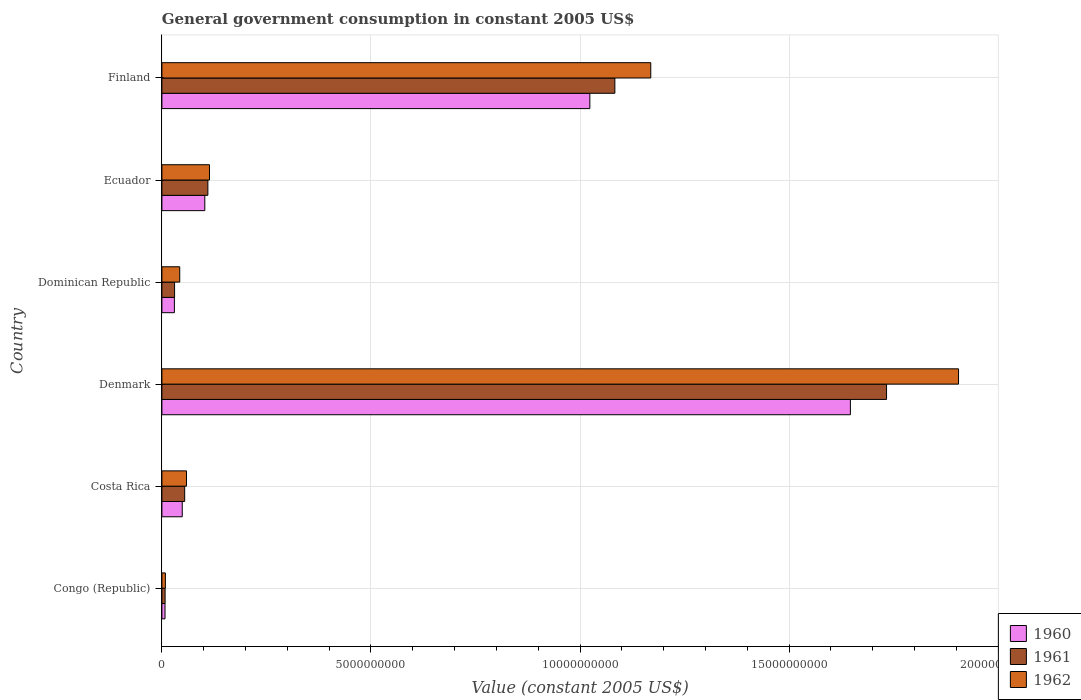How many groups of bars are there?
Keep it short and to the point. 6. Are the number of bars on each tick of the Y-axis equal?
Your answer should be compact. Yes. How many bars are there on the 5th tick from the top?
Provide a short and direct response. 3. How many bars are there on the 3rd tick from the bottom?
Make the answer very short. 3. What is the label of the 2nd group of bars from the top?
Keep it short and to the point. Ecuador. What is the government conusmption in 1962 in Costa Rica?
Make the answer very short. 5.88e+08. Across all countries, what is the maximum government conusmption in 1960?
Provide a short and direct response. 1.65e+1. Across all countries, what is the minimum government conusmption in 1960?
Ensure brevity in your answer.  7.44e+07. In which country was the government conusmption in 1960 minimum?
Make the answer very short. Congo (Republic). What is the total government conusmption in 1961 in the graph?
Offer a terse response. 3.02e+1. What is the difference between the government conusmption in 1962 in Congo (Republic) and that in Denmark?
Your answer should be compact. -1.90e+1. What is the difference between the government conusmption in 1961 in Denmark and the government conusmption in 1962 in Dominican Republic?
Offer a terse response. 1.69e+1. What is the average government conusmption in 1960 per country?
Provide a short and direct response. 4.76e+09. What is the difference between the government conusmption in 1962 and government conusmption in 1961 in Ecuador?
Provide a short and direct response. 3.85e+07. In how many countries, is the government conusmption in 1962 greater than 13000000000 US$?
Give a very brief answer. 1. What is the ratio of the government conusmption in 1962 in Congo (Republic) to that in Finland?
Provide a short and direct response. 0.01. Is the government conusmption in 1962 in Costa Rica less than that in Ecuador?
Provide a succinct answer. Yes. Is the difference between the government conusmption in 1962 in Costa Rica and Dominican Republic greater than the difference between the government conusmption in 1961 in Costa Rica and Dominican Republic?
Your response must be concise. No. What is the difference between the highest and the second highest government conusmption in 1962?
Offer a terse response. 7.36e+09. What is the difference between the highest and the lowest government conusmption in 1960?
Make the answer very short. 1.64e+1. Is the sum of the government conusmption in 1960 in Costa Rica and Ecuador greater than the maximum government conusmption in 1962 across all countries?
Offer a terse response. No. Is it the case that in every country, the sum of the government conusmption in 1961 and government conusmption in 1962 is greater than the government conusmption in 1960?
Provide a short and direct response. Yes. Are all the bars in the graph horizontal?
Provide a succinct answer. Yes. Does the graph contain any zero values?
Make the answer very short. No. Does the graph contain grids?
Your response must be concise. Yes. Where does the legend appear in the graph?
Make the answer very short. Bottom right. What is the title of the graph?
Your answer should be compact. General government consumption in constant 2005 US$. What is the label or title of the X-axis?
Give a very brief answer. Value (constant 2005 US$). What is the label or title of the Y-axis?
Your response must be concise. Country. What is the Value (constant 2005 US$) of 1960 in Congo (Republic)?
Keep it short and to the point. 7.44e+07. What is the Value (constant 2005 US$) of 1961 in Congo (Republic)?
Your answer should be very brief. 7.67e+07. What is the Value (constant 2005 US$) of 1962 in Congo (Republic)?
Offer a terse response. 8.33e+07. What is the Value (constant 2005 US$) in 1960 in Costa Rica?
Offer a terse response. 4.87e+08. What is the Value (constant 2005 US$) in 1961 in Costa Rica?
Ensure brevity in your answer.  5.45e+08. What is the Value (constant 2005 US$) of 1962 in Costa Rica?
Your answer should be very brief. 5.88e+08. What is the Value (constant 2005 US$) in 1960 in Denmark?
Make the answer very short. 1.65e+1. What is the Value (constant 2005 US$) of 1961 in Denmark?
Give a very brief answer. 1.73e+1. What is the Value (constant 2005 US$) of 1962 in Denmark?
Your response must be concise. 1.91e+1. What is the Value (constant 2005 US$) of 1960 in Dominican Republic?
Provide a succinct answer. 2.99e+08. What is the Value (constant 2005 US$) of 1961 in Dominican Republic?
Offer a very short reply. 3.03e+08. What is the Value (constant 2005 US$) of 1962 in Dominican Republic?
Your answer should be compact. 4.27e+08. What is the Value (constant 2005 US$) of 1960 in Ecuador?
Your response must be concise. 1.03e+09. What is the Value (constant 2005 US$) of 1961 in Ecuador?
Give a very brief answer. 1.10e+09. What is the Value (constant 2005 US$) of 1962 in Ecuador?
Offer a very short reply. 1.14e+09. What is the Value (constant 2005 US$) of 1960 in Finland?
Make the answer very short. 1.02e+1. What is the Value (constant 2005 US$) of 1961 in Finland?
Offer a very short reply. 1.08e+1. What is the Value (constant 2005 US$) in 1962 in Finland?
Your answer should be compact. 1.17e+1. Across all countries, what is the maximum Value (constant 2005 US$) of 1960?
Give a very brief answer. 1.65e+1. Across all countries, what is the maximum Value (constant 2005 US$) of 1961?
Give a very brief answer. 1.73e+1. Across all countries, what is the maximum Value (constant 2005 US$) of 1962?
Offer a terse response. 1.91e+1. Across all countries, what is the minimum Value (constant 2005 US$) of 1960?
Your answer should be very brief. 7.44e+07. Across all countries, what is the minimum Value (constant 2005 US$) in 1961?
Give a very brief answer. 7.67e+07. Across all countries, what is the minimum Value (constant 2005 US$) in 1962?
Give a very brief answer. 8.33e+07. What is the total Value (constant 2005 US$) in 1960 in the graph?
Offer a terse response. 2.86e+1. What is the total Value (constant 2005 US$) in 1961 in the graph?
Provide a short and direct response. 3.02e+1. What is the total Value (constant 2005 US$) in 1962 in the graph?
Your response must be concise. 3.30e+1. What is the difference between the Value (constant 2005 US$) of 1960 in Congo (Republic) and that in Costa Rica?
Ensure brevity in your answer.  -4.12e+08. What is the difference between the Value (constant 2005 US$) in 1961 in Congo (Republic) and that in Costa Rica?
Offer a very short reply. -4.68e+08. What is the difference between the Value (constant 2005 US$) in 1962 in Congo (Republic) and that in Costa Rica?
Your answer should be compact. -5.05e+08. What is the difference between the Value (constant 2005 US$) of 1960 in Congo (Republic) and that in Denmark?
Ensure brevity in your answer.  -1.64e+1. What is the difference between the Value (constant 2005 US$) in 1961 in Congo (Republic) and that in Denmark?
Make the answer very short. -1.73e+1. What is the difference between the Value (constant 2005 US$) of 1962 in Congo (Republic) and that in Denmark?
Provide a short and direct response. -1.90e+1. What is the difference between the Value (constant 2005 US$) in 1960 in Congo (Republic) and that in Dominican Republic?
Give a very brief answer. -2.24e+08. What is the difference between the Value (constant 2005 US$) in 1961 in Congo (Republic) and that in Dominican Republic?
Your answer should be very brief. -2.27e+08. What is the difference between the Value (constant 2005 US$) of 1962 in Congo (Republic) and that in Dominican Republic?
Offer a very short reply. -3.43e+08. What is the difference between the Value (constant 2005 US$) in 1960 in Congo (Republic) and that in Ecuador?
Your response must be concise. -9.51e+08. What is the difference between the Value (constant 2005 US$) in 1961 in Congo (Republic) and that in Ecuador?
Give a very brief answer. -1.02e+09. What is the difference between the Value (constant 2005 US$) of 1962 in Congo (Republic) and that in Ecuador?
Provide a short and direct response. -1.05e+09. What is the difference between the Value (constant 2005 US$) of 1960 in Congo (Republic) and that in Finland?
Provide a succinct answer. -1.02e+1. What is the difference between the Value (constant 2005 US$) in 1961 in Congo (Republic) and that in Finland?
Provide a short and direct response. -1.08e+1. What is the difference between the Value (constant 2005 US$) of 1962 in Congo (Republic) and that in Finland?
Your answer should be very brief. -1.16e+1. What is the difference between the Value (constant 2005 US$) in 1960 in Costa Rica and that in Denmark?
Your answer should be compact. -1.60e+1. What is the difference between the Value (constant 2005 US$) in 1961 in Costa Rica and that in Denmark?
Offer a terse response. -1.68e+1. What is the difference between the Value (constant 2005 US$) in 1962 in Costa Rica and that in Denmark?
Your answer should be very brief. -1.85e+1. What is the difference between the Value (constant 2005 US$) in 1960 in Costa Rica and that in Dominican Republic?
Provide a succinct answer. 1.88e+08. What is the difference between the Value (constant 2005 US$) in 1961 in Costa Rica and that in Dominican Republic?
Provide a succinct answer. 2.41e+08. What is the difference between the Value (constant 2005 US$) in 1962 in Costa Rica and that in Dominican Republic?
Ensure brevity in your answer.  1.61e+08. What is the difference between the Value (constant 2005 US$) in 1960 in Costa Rica and that in Ecuador?
Make the answer very short. -5.39e+08. What is the difference between the Value (constant 2005 US$) of 1961 in Costa Rica and that in Ecuador?
Your answer should be very brief. -5.55e+08. What is the difference between the Value (constant 2005 US$) in 1962 in Costa Rica and that in Ecuador?
Provide a succinct answer. -5.50e+08. What is the difference between the Value (constant 2005 US$) of 1960 in Costa Rica and that in Finland?
Keep it short and to the point. -9.75e+09. What is the difference between the Value (constant 2005 US$) of 1961 in Costa Rica and that in Finland?
Keep it short and to the point. -1.03e+1. What is the difference between the Value (constant 2005 US$) of 1962 in Costa Rica and that in Finland?
Your response must be concise. -1.11e+1. What is the difference between the Value (constant 2005 US$) of 1960 in Denmark and that in Dominican Republic?
Keep it short and to the point. 1.62e+1. What is the difference between the Value (constant 2005 US$) in 1961 in Denmark and that in Dominican Republic?
Make the answer very short. 1.70e+1. What is the difference between the Value (constant 2005 US$) in 1962 in Denmark and that in Dominican Republic?
Offer a very short reply. 1.86e+1. What is the difference between the Value (constant 2005 US$) in 1960 in Denmark and that in Ecuador?
Provide a short and direct response. 1.54e+1. What is the difference between the Value (constant 2005 US$) in 1961 in Denmark and that in Ecuador?
Give a very brief answer. 1.62e+1. What is the difference between the Value (constant 2005 US$) in 1962 in Denmark and that in Ecuador?
Provide a short and direct response. 1.79e+1. What is the difference between the Value (constant 2005 US$) in 1960 in Denmark and that in Finland?
Offer a terse response. 6.23e+09. What is the difference between the Value (constant 2005 US$) of 1961 in Denmark and that in Finland?
Keep it short and to the point. 6.50e+09. What is the difference between the Value (constant 2005 US$) of 1962 in Denmark and that in Finland?
Your response must be concise. 7.36e+09. What is the difference between the Value (constant 2005 US$) of 1960 in Dominican Republic and that in Ecuador?
Provide a short and direct response. -7.27e+08. What is the difference between the Value (constant 2005 US$) of 1961 in Dominican Republic and that in Ecuador?
Your answer should be compact. -7.96e+08. What is the difference between the Value (constant 2005 US$) of 1962 in Dominican Republic and that in Ecuador?
Provide a succinct answer. -7.11e+08. What is the difference between the Value (constant 2005 US$) of 1960 in Dominican Republic and that in Finland?
Ensure brevity in your answer.  -9.94e+09. What is the difference between the Value (constant 2005 US$) of 1961 in Dominican Republic and that in Finland?
Provide a succinct answer. -1.05e+1. What is the difference between the Value (constant 2005 US$) in 1962 in Dominican Republic and that in Finland?
Your answer should be very brief. -1.13e+1. What is the difference between the Value (constant 2005 US$) in 1960 in Ecuador and that in Finland?
Offer a very short reply. -9.21e+09. What is the difference between the Value (constant 2005 US$) in 1961 in Ecuador and that in Finland?
Make the answer very short. -9.73e+09. What is the difference between the Value (constant 2005 US$) of 1962 in Ecuador and that in Finland?
Your answer should be very brief. -1.06e+1. What is the difference between the Value (constant 2005 US$) in 1960 in Congo (Republic) and the Value (constant 2005 US$) in 1961 in Costa Rica?
Give a very brief answer. -4.70e+08. What is the difference between the Value (constant 2005 US$) of 1960 in Congo (Republic) and the Value (constant 2005 US$) of 1962 in Costa Rica?
Offer a terse response. -5.13e+08. What is the difference between the Value (constant 2005 US$) of 1961 in Congo (Republic) and the Value (constant 2005 US$) of 1962 in Costa Rica?
Your answer should be very brief. -5.11e+08. What is the difference between the Value (constant 2005 US$) in 1960 in Congo (Republic) and the Value (constant 2005 US$) in 1961 in Denmark?
Your answer should be compact. -1.73e+1. What is the difference between the Value (constant 2005 US$) of 1960 in Congo (Republic) and the Value (constant 2005 US$) of 1962 in Denmark?
Ensure brevity in your answer.  -1.90e+1. What is the difference between the Value (constant 2005 US$) of 1961 in Congo (Republic) and the Value (constant 2005 US$) of 1962 in Denmark?
Give a very brief answer. -1.90e+1. What is the difference between the Value (constant 2005 US$) in 1960 in Congo (Republic) and the Value (constant 2005 US$) in 1961 in Dominican Republic?
Your response must be concise. -2.29e+08. What is the difference between the Value (constant 2005 US$) of 1960 in Congo (Republic) and the Value (constant 2005 US$) of 1962 in Dominican Republic?
Your answer should be very brief. -3.52e+08. What is the difference between the Value (constant 2005 US$) in 1961 in Congo (Republic) and the Value (constant 2005 US$) in 1962 in Dominican Republic?
Provide a succinct answer. -3.50e+08. What is the difference between the Value (constant 2005 US$) in 1960 in Congo (Republic) and the Value (constant 2005 US$) in 1961 in Ecuador?
Your response must be concise. -1.02e+09. What is the difference between the Value (constant 2005 US$) in 1960 in Congo (Republic) and the Value (constant 2005 US$) in 1962 in Ecuador?
Offer a terse response. -1.06e+09. What is the difference between the Value (constant 2005 US$) of 1961 in Congo (Republic) and the Value (constant 2005 US$) of 1962 in Ecuador?
Keep it short and to the point. -1.06e+09. What is the difference between the Value (constant 2005 US$) in 1960 in Congo (Republic) and the Value (constant 2005 US$) in 1961 in Finland?
Your answer should be compact. -1.08e+1. What is the difference between the Value (constant 2005 US$) in 1960 in Congo (Republic) and the Value (constant 2005 US$) in 1962 in Finland?
Offer a very short reply. -1.16e+1. What is the difference between the Value (constant 2005 US$) of 1961 in Congo (Republic) and the Value (constant 2005 US$) of 1962 in Finland?
Make the answer very short. -1.16e+1. What is the difference between the Value (constant 2005 US$) of 1960 in Costa Rica and the Value (constant 2005 US$) of 1961 in Denmark?
Keep it short and to the point. -1.68e+1. What is the difference between the Value (constant 2005 US$) in 1960 in Costa Rica and the Value (constant 2005 US$) in 1962 in Denmark?
Keep it short and to the point. -1.86e+1. What is the difference between the Value (constant 2005 US$) in 1961 in Costa Rica and the Value (constant 2005 US$) in 1962 in Denmark?
Provide a succinct answer. -1.85e+1. What is the difference between the Value (constant 2005 US$) in 1960 in Costa Rica and the Value (constant 2005 US$) in 1961 in Dominican Republic?
Make the answer very short. 1.83e+08. What is the difference between the Value (constant 2005 US$) in 1960 in Costa Rica and the Value (constant 2005 US$) in 1962 in Dominican Republic?
Offer a terse response. 6.01e+07. What is the difference between the Value (constant 2005 US$) of 1961 in Costa Rica and the Value (constant 2005 US$) of 1962 in Dominican Republic?
Ensure brevity in your answer.  1.18e+08. What is the difference between the Value (constant 2005 US$) in 1960 in Costa Rica and the Value (constant 2005 US$) in 1961 in Ecuador?
Your response must be concise. -6.13e+08. What is the difference between the Value (constant 2005 US$) of 1960 in Costa Rica and the Value (constant 2005 US$) of 1962 in Ecuador?
Ensure brevity in your answer.  -6.51e+08. What is the difference between the Value (constant 2005 US$) in 1961 in Costa Rica and the Value (constant 2005 US$) in 1962 in Ecuador?
Offer a terse response. -5.93e+08. What is the difference between the Value (constant 2005 US$) in 1960 in Costa Rica and the Value (constant 2005 US$) in 1961 in Finland?
Ensure brevity in your answer.  -1.03e+1. What is the difference between the Value (constant 2005 US$) of 1960 in Costa Rica and the Value (constant 2005 US$) of 1962 in Finland?
Offer a terse response. -1.12e+1. What is the difference between the Value (constant 2005 US$) of 1961 in Costa Rica and the Value (constant 2005 US$) of 1962 in Finland?
Provide a short and direct response. -1.11e+1. What is the difference between the Value (constant 2005 US$) of 1960 in Denmark and the Value (constant 2005 US$) of 1961 in Dominican Republic?
Give a very brief answer. 1.62e+1. What is the difference between the Value (constant 2005 US$) of 1960 in Denmark and the Value (constant 2005 US$) of 1962 in Dominican Republic?
Give a very brief answer. 1.60e+1. What is the difference between the Value (constant 2005 US$) in 1961 in Denmark and the Value (constant 2005 US$) in 1962 in Dominican Republic?
Your response must be concise. 1.69e+1. What is the difference between the Value (constant 2005 US$) of 1960 in Denmark and the Value (constant 2005 US$) of 1961 in Ecuador?
Make the answer very short. 1.54e+1. What is the difference between the Value (constant 2005 US$) in 1960 in Denmark and the Value (constant 2005 US$) in 1962 in Ecuador?
Make the answer very short. 1.53e+1. What is the difference between the Value (constant 2005 US$) of 1961 in Denmark and the Value (constant 2005 US$) of 1962 in Ecuador?
Keep it short and to the point. 1.62e+1. What is the difference between the Value (constant 2005 US$) of 1960 in Denmark and the Value (constant 2005 US$) of 1961 in Finland?
Provide a short and direct response. 5.63e+09. What is the difference between the Value (constant 2005 US$) of 1960 in Denmark and the Value (constant 2005 US$) of 1962 in Finland?
Make the answer very short. 4.77e+09. What is the difference between the Value (constant 2005 US$) of 1961 in Denmark and the Value (constant 2005 US$) of 1962 in Finland?
Offer a terse response. 5.64e+09. What is the difference between the Value (constant 2005 US$) of 1960 in Dominican Republic and the Value (constant 2005 US$) of 1961 in Ecuador?
Your response must be concise. -8.01e+08. What is the difference between the Value (constant 2005 US$) of 1960 in Dominican Republic and the Value (constant 2005 US$) of 1962 in Ecuador?
Ensure brevity in your answer.  -8.39e+08. What is the difference between the Value (constant 2005 US$) of 1961 in Dominican Republic and the Value (constant 2005 US$) of 1962 in Ecuador?
Give a very brief answer. -8.35e+08. What is the difference between the Value (constant 2005 US$) in 1960 in Dominican Republic and the Value (constant 2005 US$) in 1961 in Finland?
Provide a succinct answer. -1.05e+1. What is the difference between the Value (constant 2005 US$) of 1960 in Dominican Republic and the Value (constant 2005 US$) of 1962 in Finland?
Ensure brevity in your answer.  -1.14e+1. What is the difference between the Value (constant 2005 US$) in 1961 in Dominican Republic and the Value (constant 2005 US$) in 1962 in Finland?
Provide a short and direct response. -1.14e+1. What is the difference between the Value (constant 2005 US$) of 1960 in Ecuador and the Value (constant 2005 US$) of 1961 in Finland?
Offer a terse response. -9.81e+09. What is the difference between the Value (constant 2005 US$) of 1960 in Ecuador and the Value (constant 2005 US$) of 1962 in Finland?
Ensure brevity in your answer.  -1.07e+1. What is the difference between the Value (constant 2005 US$) of 1961 in Ecuador and the Value (constant 2005 US$) of 1962 in Finland?
Provide a succinct answer. -1.06e+1. What is the average Value (constant 2005 US$) in 1960 per country?
Provide a short and direct response. 4.76e+09. What is the average Value (constant 2005 US$) of 1961 per country?
Ensure brevity in your answer.  5.03e+09. What is the average Value (constant 2005 US$) in 1962 per country?
Ensure brevity in your answer.  5.50e+09. What is the difference between the Value (constant 2005 US$) of 1960 and Value (constant 2005 US$) of 1961 in Congo (Republic)?
Give a very brief answer. -2.22e+06. What is the difference between the Value (constant 2005 US$) of 1960 and Value (constant 2005 US$) of 1962 in Congo (Republic)?
Offer a terse response. -8.89e+06. What is the difference between the Value (constant 2005 US$) of 1961 and Value (constant 2005 US$) of 1962 in Congo (Republic)?
Provide a short and direct response. -6.67e+06. What is the difference between the Value (constant 2005 US$) in 1960 and Value (constant 2005 US$) in 1961 in Costa Rica?
Provide a succinct answer. -5.79e+07. What is the difference between the Value (constant 2005 US$) of 1960 and Value (constant 2005 US$) of 1962 in Costa Rica?
Ensure brevity in your answer.  -1.01e+08. What is the difference between the Value (constant 2005 US$) in 1961 and Value (constant 2005 US$) in 1962 in Costa Rica?
Your response must be concise. -4.32e+07. What is the difference between the Value (constant 2005 US$) in 1960 and Value (constant 2005 US$) in 1961 in Denmark?
Your answer should be very brief. -8.65e+08. What is the difference between the Value (constant 2005 US$) of 1960 and Value (constant 2005 US$) of 1962 in Denmark?
Ensure brevity in your answer.  -2.59e+09. What is the difference between the Value (constant 2005 US$) in 1961 and Value (constant 2005 US$) in 1962 in Denmark?
Provide a succinct answer. -1.72e+09. What is the difference between the Value (constant 2005 US$) of 1960 and Value (constant 2005 US$) of 1961 in Dominican Republic?
Your answer should be very brief. -4.75e+06. What is the difference between the Value (constant 2005 US$) of 1960 and Value (constant 2005 US$) of 1962 in Dominican Republic?
Offer a very short reply. -1.28e+08. What is the difference between the Value (constant 2005 US$) in 1961 and Value (constant 2005 US$) in 1962 in Dominican Republic?
Provide a short and direct response. -1.23e+08. What is the difference between the Value (constant 2005 US$) of 1960 and Value (constant 2005 US$) of 1961 in Ecuador?
Provide a succinct answer. -7.35e+07. What is the difference between the Value (constant 2005 US$) in 1960 and Value (constant 2005 US$) in 1962 in Ecuador?
Provide a short and direct response. -1.12e+08. What is the difference between the Value (constant 2005 US$) in 1961 and Value (constant 2005 US$) in 1962 in Ecuador?
Ensure brevity in your answer.  -3.85e+07. What is the difference between the Value (constant 2005 US$) in 1960 and Value (constant 2005 US$) in 1961 in Finland?
Offer a very short reply. -5.98e+08. What is the difference between the Value (constant 2005 US$) of 1960 and Value (constant 2005 US$) of 1962 in Finland?
Make the answer very short. -1.46e+09. What is the difference between the Value (constant 2005 US$) of 1961 and Value (constant 2005 US$) of 1962 in Finland?
Provide a short and direct response. -8.59e+08. What is the ratio of the Value (constant 2005 US$) in 1960 in Congo (Republic) to that in Costa Rica?
Keep it short and to the point. 0.15. What is the ratio of the Value (constant 2005 US$) in 1961 in Congo (Republic) to that in Costa Rica?
Provide a short and direct response. 0.14. What is the ratio of the Value (constant 2005 US$) in 1962 in Congo (Republic) to that in Costa Rica?
Your response must be concise. 0.14. What is the ratio of the Value (constant 2005 US$) in 1960 in Congo (Republic) to that in Denmark?
Keep it short and to the point. 0. What is the ratio of the Value (constant 2005 US$) in 1961 in Congo (Republic) to that in Denmark?
Ensure brevity in your answer.  0. What is the ratio of the Value (constant 2005 US$) of 1962 in Congo (Republic) to that in Denmark?
Your answer should be very brief. 0. What is the ratio of the Value (constant 2005 US$) of 1960 in Congo (Republic) to that in Dominican Republic?
Provide a short and direct response. 0.25. What is the ratio of the Value (constant 2005 US$) in 1961 in Congo (Republic) to that in Dominican Republic?
Make the answer very short. 0.25. What is the ratio of the Value (constant 2005 US$) of 1962 in Congo (Republic) to that in Dominican Republic?
Your answer should be very brief. 0.2. What is the ratio of the Value (constant 2005 US$) in 1960 in Congo (Republic) to that in Ecuador?
Your answer should be very brief. 0.07. What is the ratio of the Value (constant 2005 US$) in 1961 in Congo (Republic) to that in Ecuador?
Ensure brevity in your answer.  0.07. What is the ratio of the Value (constant 2005 US$) of 1962 in Congo (Republic) to that in Ecuador?
Your answer should be very brief. 0.07. What is the ratio of the Value (constant 2005 US$) of 1960 in Congo (Republic) to that in Finland?
Provide a short and direct response. 0.01. What is the ratio of the Value (constant 2005 US$) of 1961 in Congo (Republic) to that in Finland?
Offer a very short reply. 0.01. What is the ratio of the Value (constant 2005 US$) of 1962 in Congo (Republic) to that in Finland?
Offer a very short reply. 0.01. What is the ratio of the Value (constant 2005 US$) in 1960 in Costa Rica to that in Denmark?
Provide a succinct answer. 0.03. What is the ratio of the Value (constant 2005 US$) in 1961 in Costa Rica to that in Denmark?
Provide a short and direct response. 0.03. What is the ratio of the Value (constant 2005 US$) of 1962 in Costa Rica to that in Denmark?
Make the answer very short. 0.03. What is the ratio of the Value (constant 2005 US$) in 1960 in Costa Rica to that in Dominican Republic?
Give a very brief answer. 1.63. What is the ratio of the Value (constant 2005 US$) in 1961 in Costa Rica to that in Dominican Republic?
Offer a terse response. 1.8. What is the ratio of the Value (constant 2005 US$) in 1962 in Costa Rica to that in Dominican Republic?
Offer a very short reply. 1.38. What is the ratio of the Value (constant 2005 US$) of 1960 in Costa Rica to that in Ecuador?
Your answer should be compact. 0.47. What is the ratio of the Value (constant 2005 US$) in 1961 in Costa Rica to that in Ecuador?
Your response must be concise. 0.5. What is the ratio of the Value (constant 2005 US$) in 1962 in Costa Rica to that in Ecuador?
Provide a short and direct response. 0.52. What is the ratio of the Value (constant 2005 US$) of 1960 in Costa Rica to that in Finland?
Provide a succinct answer. 0.05. What is the ratio of the Value (constant 2005 US$) of 1961 in Costa Rica to that in Finland?
Make the answer very short. 0.05. What is the ratio of the Value (constant 2005 US$) of 1962 in Costa Rica to that in Finland?
Your answer should be very brief. 0.05. What is the ratio of the Value (constant 2005 US$) in 1960 in Denmark to that in Dominican Republic?
Provide a succinct answer. 55.14. What is the ratio of the Value (constant 2005 US$) of 1961 in Denmark to that in Dominican Republic?
Your answer should be very brief. 57.13. What is the ratio of the Value (constant 2005 US$) of 1962 in Denmark to that in Dominican Republic?
Provide a short and direct response. 44.66. What is the ratio of the Value (constant 2005 US$) of 1960 in Denmark to that in Ecuador?
Make the answer very short. 16.05. What is the ratio of the Value (constant 2005 US$) of 1961 in Denmark to that in Ecuador?
Provide a succinct answer. 15.76. What is the ratio of the Value (constant 2005 US$) in 1962 in Denmark to that in Ecuador?
Offer a very short reply. 16.74. What is the ratio of the Value (constant 2005 US$) of 1960 in Denmark to that in Finland?
Your response must be concise. 1.61. What is the ratio of the Value (constant 2005 US$) in 1961 in Denmark to that in Finland?
Give a very brief answer. 1.6. What is the ratio of the Value (constant 2005 US$) in 1962 in Denmark to that in Finland?
Your answer should be very brief. 1.63. What is the ratio of the Value (constant 2005 US$) in 1960 in Dominican Republic to that in Ecuador?
Make the answer very short. 0.29. What is the ratio of the Value (constant 2005 US$) of 1961 in Dominican Republic to that in Ecuador?
Provide a short and direct response. 0.28. What is the ratio of the Value (constant 2005 US$) in 1962 in Dominican Republic to that in Ecuador?
Provide a succinct answer. 0.37. What is the ratio of the Value (constant 2005 US$) in 1960 in Dominican Republic to that in Finland?
Your answer should be very brief. 0.03. What is the ratio of the Value (constant 2005 US$) of 1961 in Dominican Republic to that in Finland?
Your answer should be very brief. 0.03. What is the ratio of the Value (constant 2005 US$) in 1962 in Dominican Republic to that in Finland?
Your answer should be compact. 0.04. What is the ratio of the Value (constant 2005 US$) of 1960 in Ecuador to that in Finland?
Your response must be concise. 0.1. What is the ratio of the Value (constant 2005 US$) in 1961 in Ecuador to that in Finland?
Provide a short and direct response. 0.1. What is the ratio of the Value (constant 2005 US$) of 1962 in Ecuador to that in Finland?
Make the answer very short. 0.1. What is the difference between the highest and the second highest Value (constant 2005 US$) in 1960?
Ensure brevity in your answer.  6.23e+09. What is the difference between the highest and the second highest Value (constant 2005 US$) in 1961?
Offer a very short reply. 6.50e+09. What is the difference between the highest and the second highest Value (constant 2005 US$) of 1962?
Provide a short and direct response. 7.36e+09. What is the difference between the highest and the lowest Value (constant 2005 US$) in 1960?
Keep it short and to the point. 1.64e+1. What is the difference between the highest and the lowest Value (constant 2005 US$) in 1961?
Offer a very short reply. 1.73e+1. What is the difference between the highest and the lowest Value (constant 2005 US$) of 1962?
Make the answer very short. 1.90e+1. 